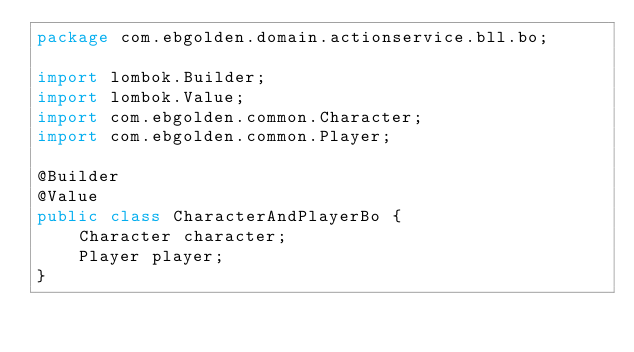<code> <loc_0><loc_0><loc_500><loc_500><_Java_>package com.ebgolden.domain.actionservice.bll.bo;

import lombok.Builder;
import lombok.Value;
import com.ebgolden.common.Character;
import com.ebgolden.common.Player;

@Builder
@Value
public class CharacterAndPlayerBo {
    Character character;
    Player player;
}</code> 